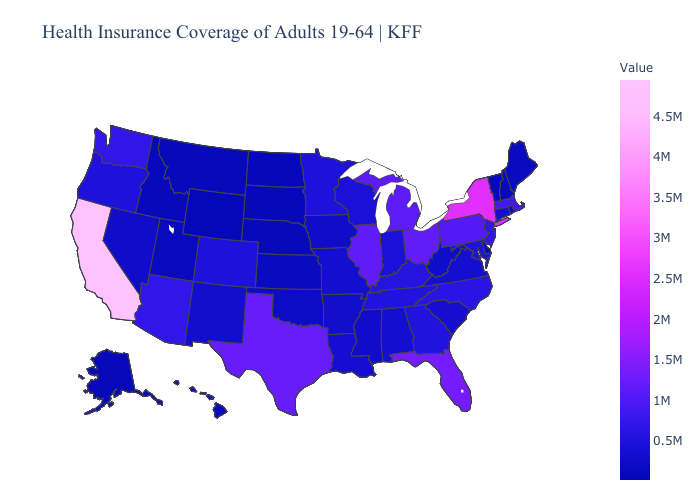Among the states that border Iowa , does South Dakota have the lowest value?
Write a very short answer. Yes. Among the states that border Utah , does New Mexico have the highest value?
Give a very brief answer. No. Among the states that border Massachusetts , which have the lowest value?
Be succinct. New Hampshire. Which states have the lowest value in the West?
Give a very brief answer. Wyoming. Does Washington have the lowest value in the West?
Be succinct. No. 